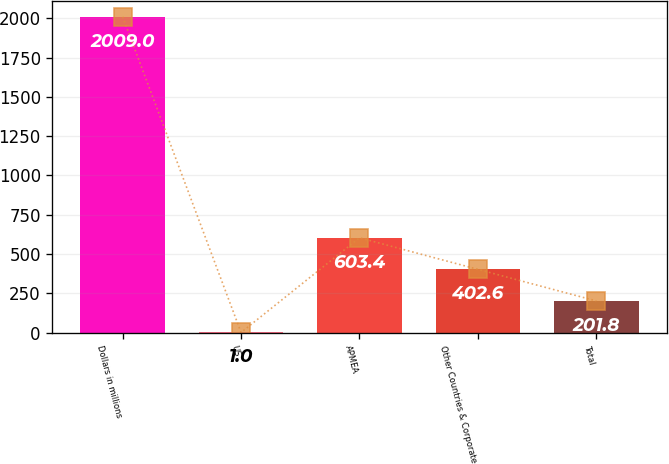Convert chart to OTSL. <chart><loc_0><loc_0><loc_500><loc_500><bar_chart><fcel>Dollars in millions<fcel>US<fcel>APMEA<fcel>Other Countries & Corporate<fcel>Total<nl><fcel>2009<fcel>1<fcel>603.4<fcel>402.6<fcel>201.8<nl></chart> 